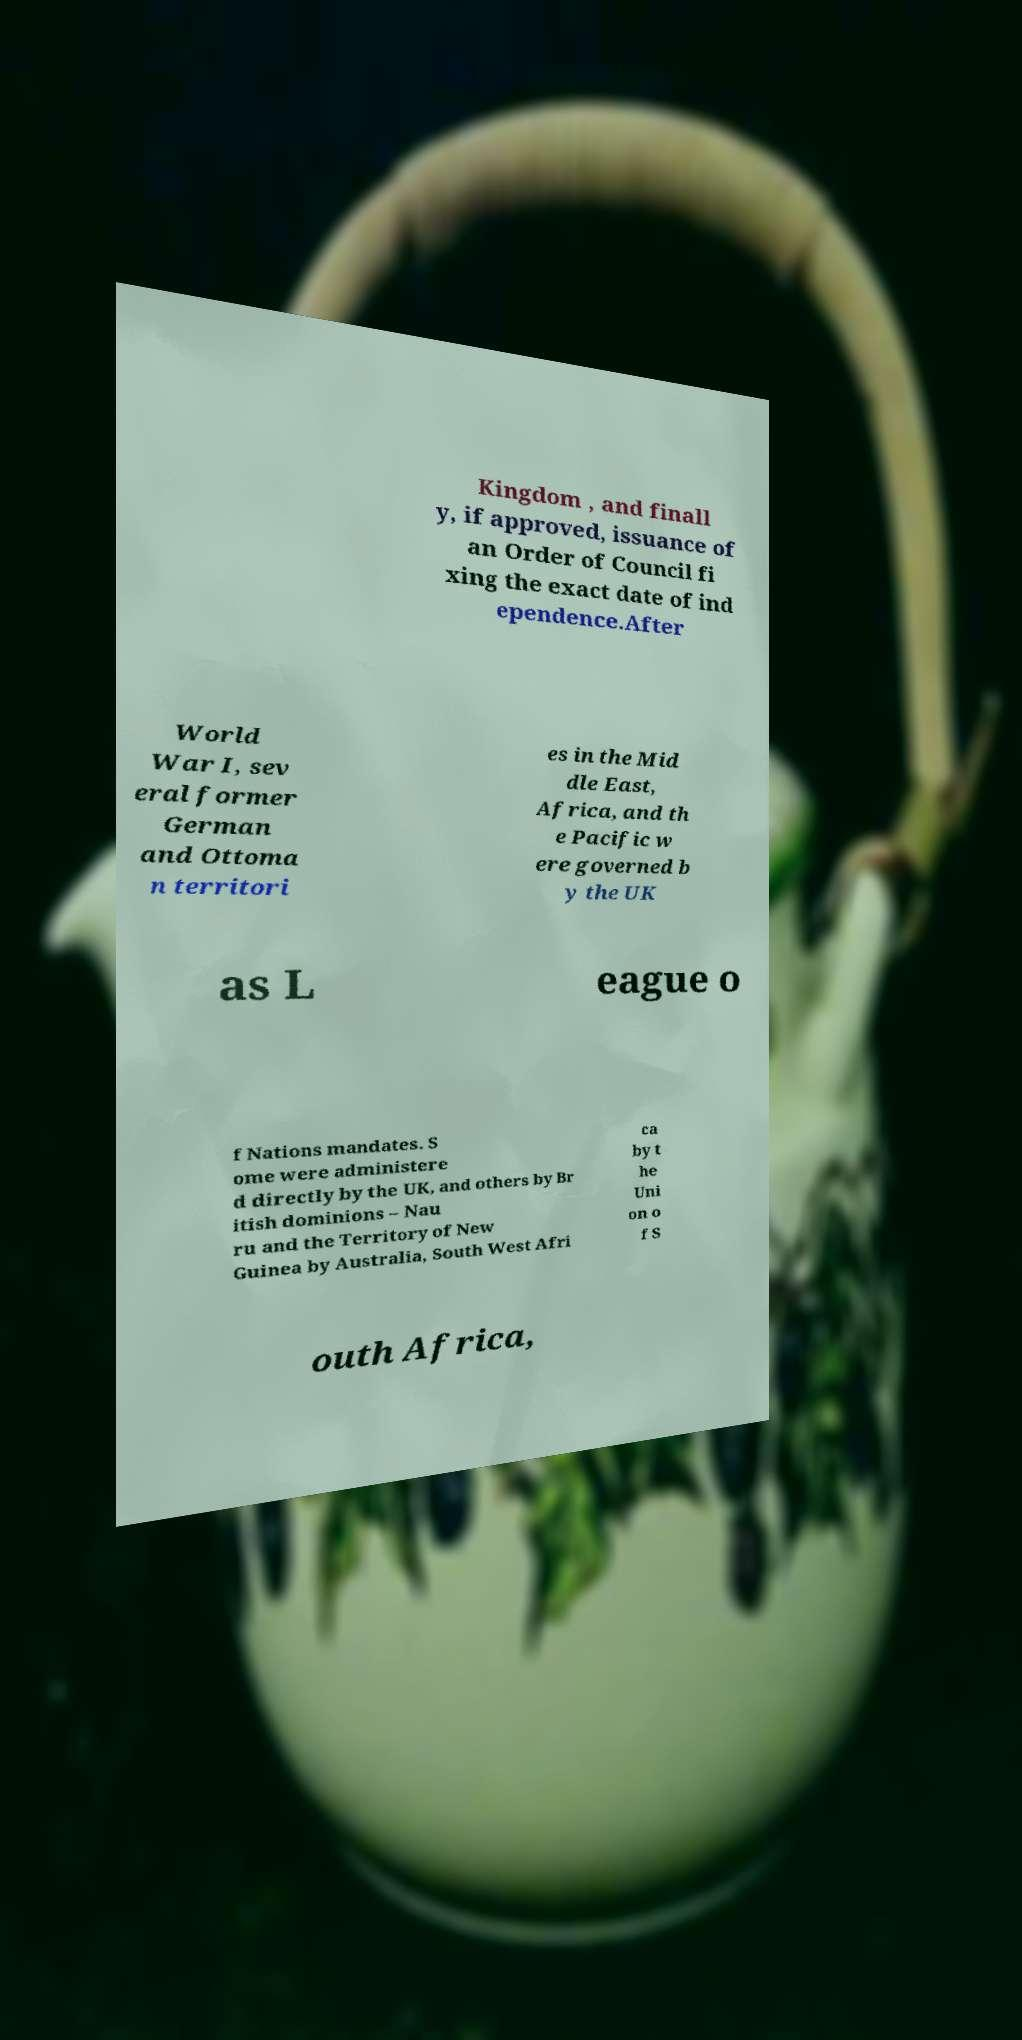Can you read and provide the text displayed in the image?This photo seems to have some interesting text. Can you extract and type it out for me? Kingdom , and finall y, if approved, issuance of an Order of Council fi xing the exact date of ind ependence.After World War I, sev eral former German and Ottoma n territori es in the Mid dle East, Africa, and th e Pacific w ere governed b y the UK as L eague o f Nations mandates. S ome were administere d directly by the UK, and others by Br itish dominions – Nau ru and the Territory of New Guinea by Australia, South West Afri ca by t he Uni on o f S outh Africa, 